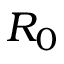Convert formula to latex. <formula><loc_0><loc_0><loc_500><loc_500>R _ { 0 }</formula> 